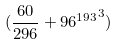<formula> <loc_0><loc_0><loc_500><loc_500>( \frac { 6 0 } { 2 9 6 } + { 9 6 ^ { 1 9 3 } } ^ { 3 } )</formula> 